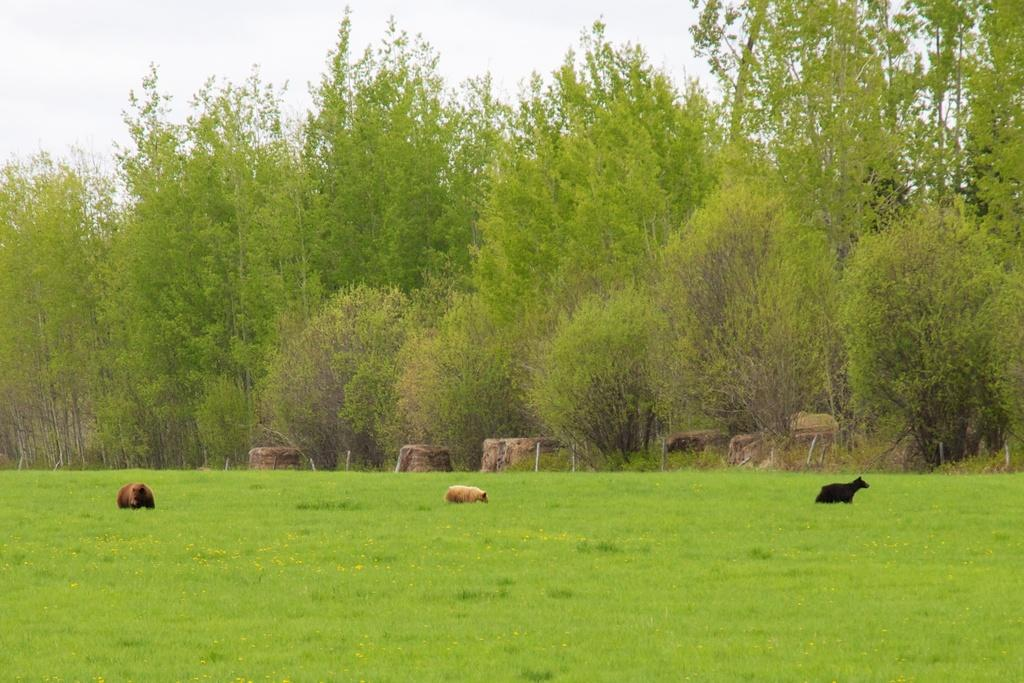What type of living organisms can be seen in the image? There are animals in the image. What type of vegetation is present in the image? There is grass in the image. What can be seen in the background of the image? There are trees and the sky visible in the background of the image. What letters are written on the floor in the image? There is no mention of a floor or letters in the image; it features animals, grass, trees, and the sky. 